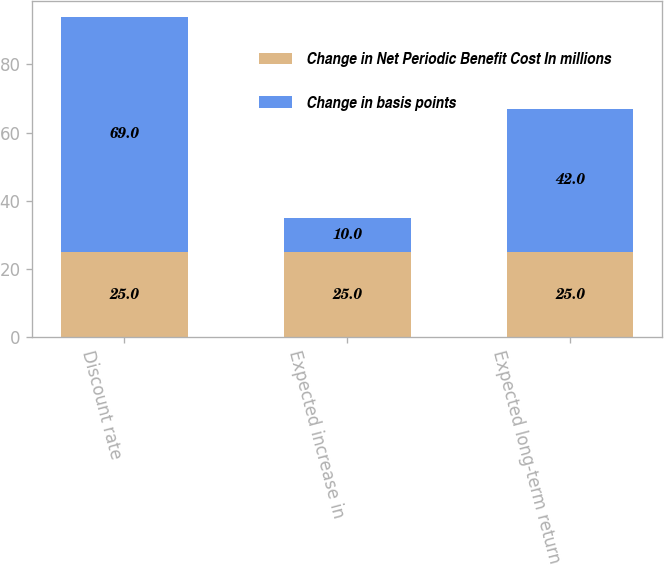Convert chart to OTSL. <chart><loc_0><loc_0><loc_500><loc_500><stacked_bar_chart><ecel><fcel>Discount rate<fcel>Expected increase in<fcel>Expected long-term return on<nl><fcel>Change in Net Periodic Benefit Cost In millions<fcel>25<fcel>25<fcel>25<nl><fcel>Change in basis points<fcel>69<fcel>10<fcel>42<nl></chart> 